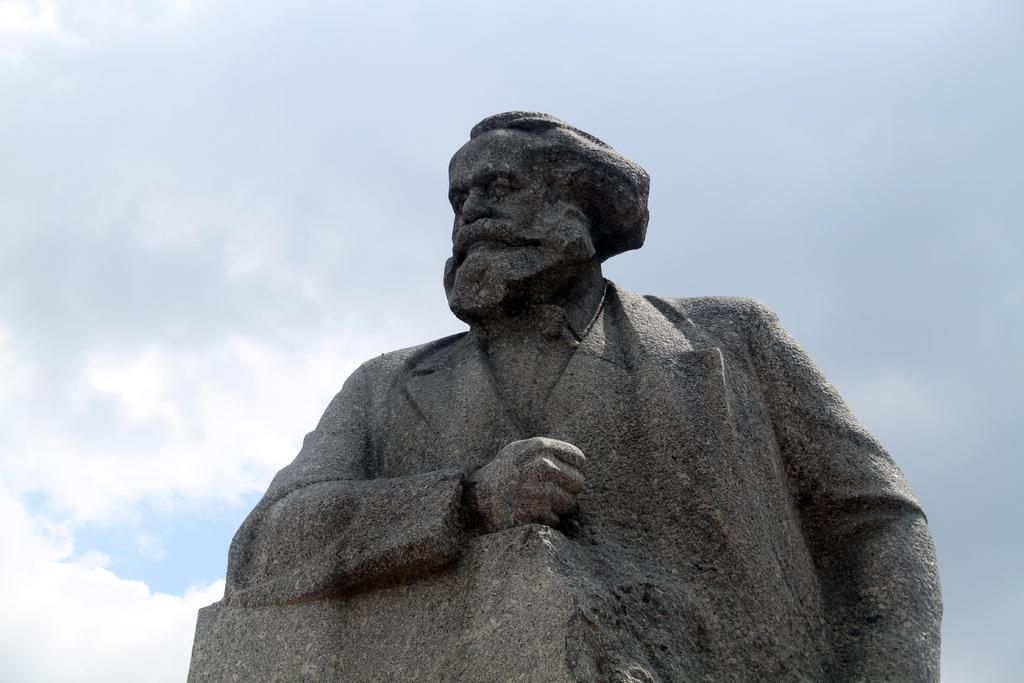What is the main subject of the image? There is a statue of a person in the image. What color is the statue? The statue is grey in color. What can be seen in the background of the image? There are clouds and the sky visible in the background of the image. How many girls are playing a musical instrument in the image? There are no girls or musical instruments present in the image; it features a statue of a person and a background with clouds and the sky. 